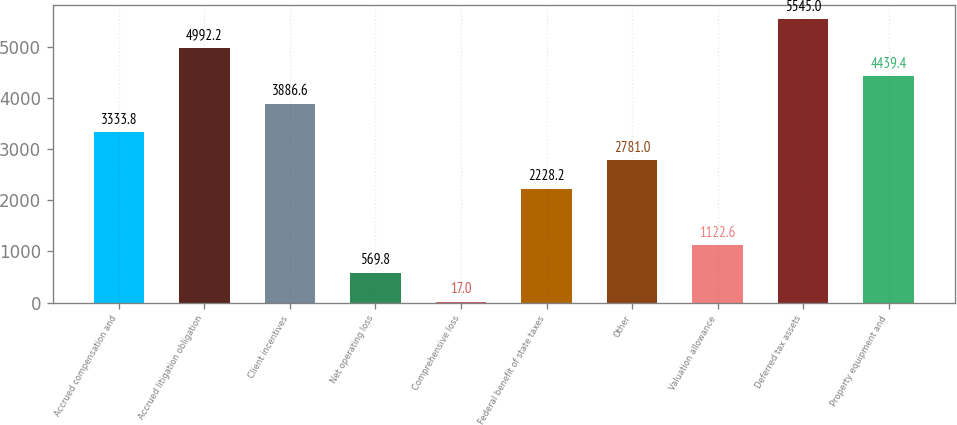Convert chart. <chart><loc_0><loc_0><loc_500><loc_500><bar_chart><fcel>Accrued compensation and<fcel>Accrued litigation obligation<fcel>Client incentives<fcel>Net operating loss<fcel>Comprehensive loss<fcel>Federal benefit of state taxes<fcel>Other<fcel>Valuation allowance<fcel>Deferred tax assets<fcel>Property equipment and<nl><fcel>3333.8<fcel>4992.2<fcel>3886.6<fcel>569.8<fcel>17<fcel>2228.2<fcel>2781<fcel>1122.6<fcel>5545<fcel>4439.4<nl></chart> 